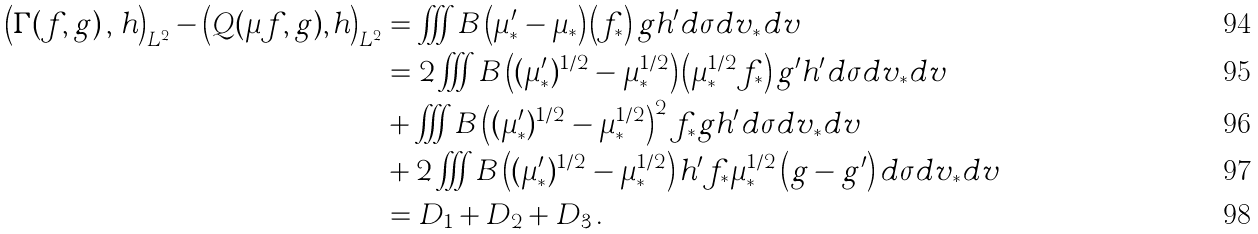<formula> <loc_0><loc_0><loc_500><loc_500>\left ( \Gamma ( f , g ) \, , \, h \right ) _ { L ^ { 2 } } - \left ( Q ( \mu f , g ) , h \right ) _ { L ^ { 2 } } & = \iiint B \left ( \mu ^ { \prime } _ { * } - \mu _ { * } \right ) \left ( f _ { * } \right ) g h ^ { \prime } d \sigma d v _ { * } d v \\ & = 2 \iiint B \left ( ( \mu ^ { \prime } _ { * } ) ^ { 1 / 2 } - \mu _ { * } ^ { 1 / 2 } \right ) \left ( \mu _ { * } ^ { 1 / 2 } f _ { * } \right ) g ^ { \prime } h ^ { \prime } d \sigma d v _ { * } d v \\ & + \iiint B \left ( ( \mu ^ { \prime } _ { * } ) ^ { 1 / 2 } - \mu _ { * } ^ { 1 / 2 } \right ) ^ { 2 } f _ { * } g h ^ { \prime } d \sigma d v _ { * } d v \\ & + 2 \iiint B \left ( ( \mu ^ { \prime } _ { * } ) ^ { 1 / 2 } - \mu _ { * } ^ { 1 / 2 } \right ) h ^ { \prime } f _ { * } \mu _ { * } ^ { 1 / 2 } \left ( g - g ^ { \prime } \right ) d \sigma d v _ { * } d v \\ & = D _ { 1 } + D _ { 2 } + D _ { 3 } \, .</formula> 